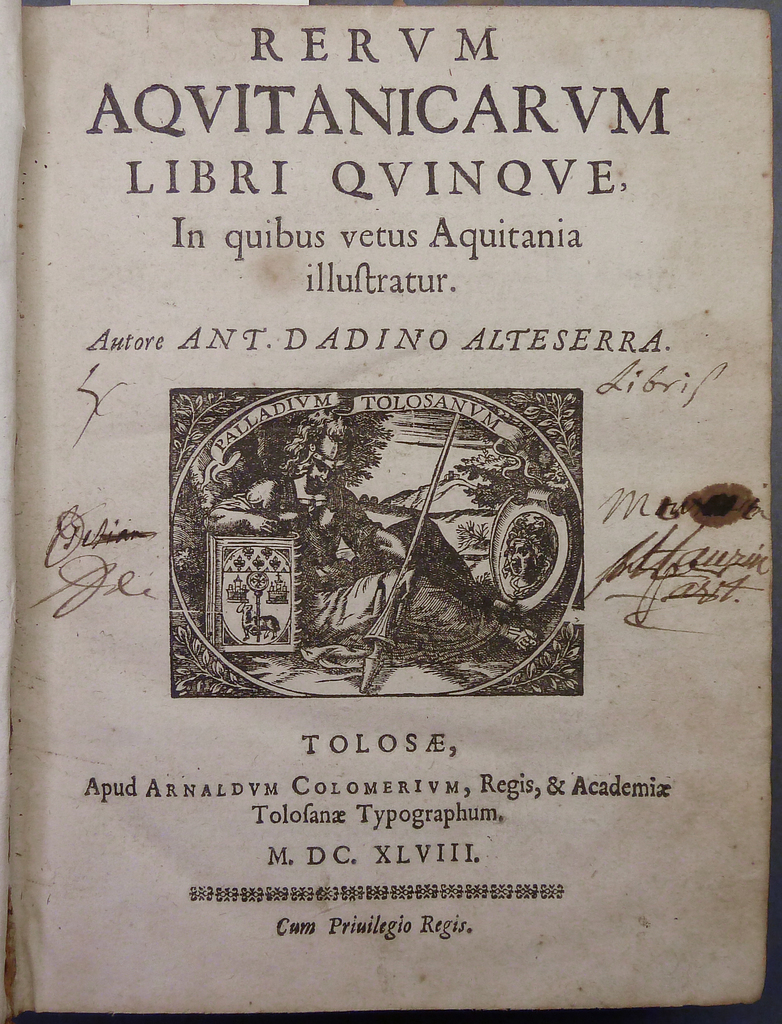Explain the significance of the 'Cum Privilegio Regis' on the bottom of the page. 'Cum Privilegio Regis' translates to 'With the King's Privilege,' indicating that this publication was created with a special license granted by the monarchy. This seal of approval not only suggests the book had content worthy of royal endorsement but also that it was expected to adhere to high standards of accuracy and quality, often serving as an official or semi-official source of information. 